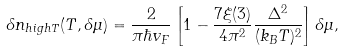<formula> <loc_0><loc_0><loc_500><loc_500>\delta n _ { h i g h T } ( T , \delta \mu ) = \frac { 2 } { \pi \hbar { v } _ { F } } \left [ 1 - \frac { 7 \xi ( 3 ) } { 4 \pi ^ { 2 } } \frac { \Delta ^ { 2 } } { ( k _ { B } T ) ^ { 2 } } \right ] \delta \mu ,</formula> 